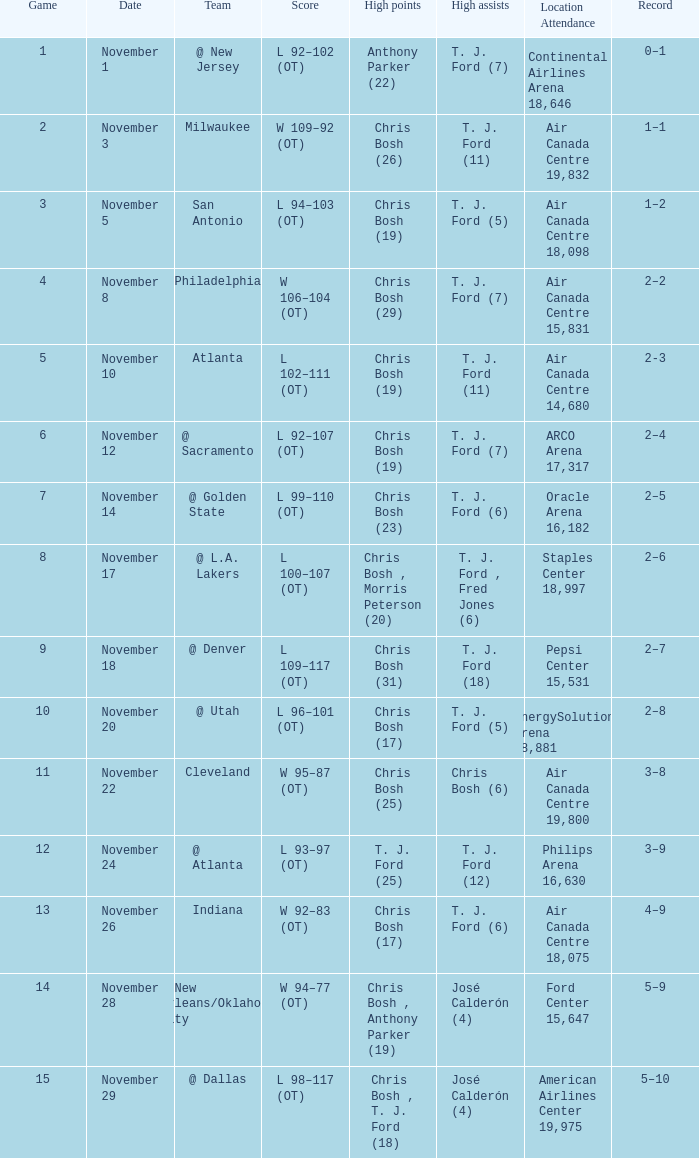What team played on November 28? @ New Orleans/Oklahoma City. 